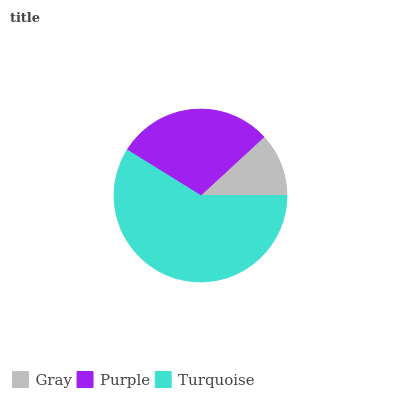Is Gray the minimum?
Answer yes or no. Yes. Is Turquoise the maximum?
Answer yes or no. Yes. Is Purple the minimum?
Answer yes or no. No. Is Purple the maximum?
Answer yes or no. No. Is Purple greater than Gray?
Answer yes or no. Yes. Is Gray less than Purple?
Answer yes or no. Yes. Is Gray greater than Purple?
Answer yes or no. No. Is Purple less than Gray?
Answer yes or no. No. Is Purple the high median?
Answer yes or no. Yes. Is Purple the low median?
Answer yes or no. Yes. Is Turquoise the high median?
Answer yes or no. No. Is Turquoise the low median?
Answer yes or no. No. 